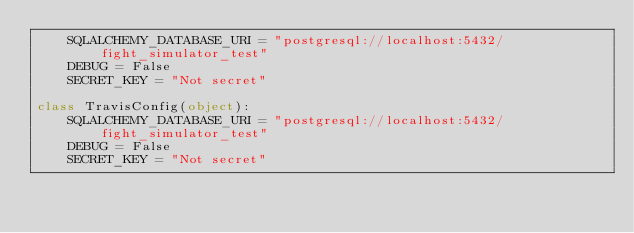<code> <loc_0><loc_0><loc_500><loc_500><_Python_>    SQLALCHEMY_DATABASE_URI = "postgresql://localhost:5432/fight_simulator_test"
    DEBUG = False
    SECRET_KEY = "Not secret"

class TravisConfig(object):
    SQLALCHEMY_DATABASE_URI = "postgresql://localhost:5432/fight_simulator_test"
    DEBUG = False
    SECRET_KEY = "Not secret"
</code> 